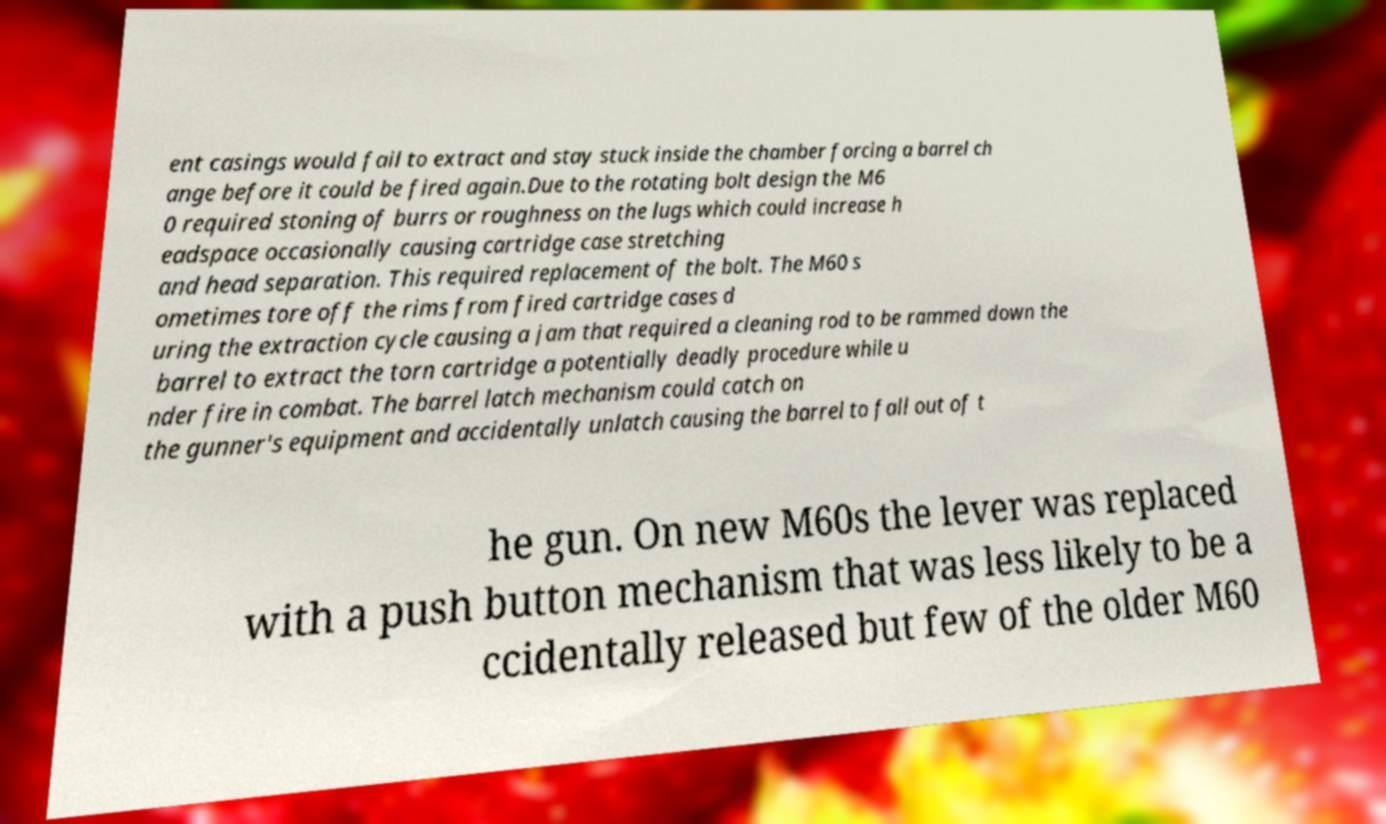Could you extract and type out the text from this image? ent casings would fail to extract and stay stuck inside the chamber forcing a barrel ch ange before it could be fired again.Due to the rotating bolt design the M6 0 required stoning of burrs or roughness on the lugs which could increase h eadspace occasionally causing cartridge case stretching and head separation. This required replacement of the bolt. The M60 s ometimes tore off the rims from fired cartridge cases d uring the extraction cycle causing a jam that required a cleaning rod to be rammed down the barrel to extract the torn cartridge a potentially deadly procedure while u nder fire in combat. The barrel latch mechanism could catch on the gunner's equipment and accidentally unlatch causing the barrel to fall out of t he gun. On new M60s the lever was replaced with a push button mechanism that was less likely to be a ccidentally released but few of the older M60 